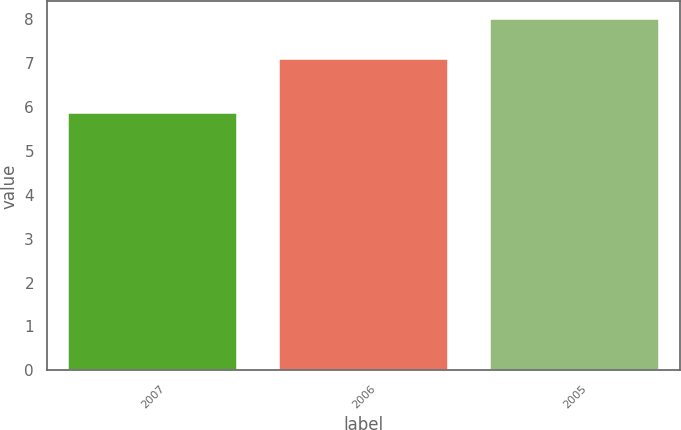<chart> <loc_0><loc_0><loc_500><loc_500><bar_chart><fcel>2007<fcel>2006<fcel>2005<nl><fcel>5.87<fcel>7.09<fcel>8.01<nl></chart> 